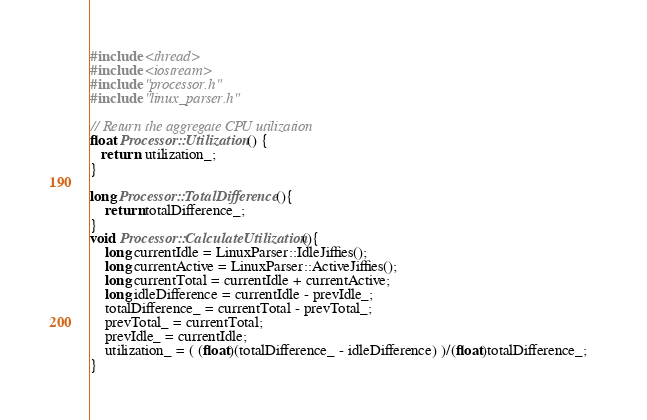<code> <loc_0><loc_0><loc_500><loc_500><_C++_>#include <thread>
#include <iostream>
#include "processor.h"
#include "linux_parser.h"

// Return the aggregate CPU utilization
float Processor::Utilization() {
   return  utilization_; 
}

long Processor::TotalDifference(){
    return totalDifference_;
}
void Processor::CalculateUtilization(){
    long currentIdle = LinuxParser::IdleJiffies();
    long currentActive = LinuxParser::ActiveJiffies();
    long currentTotal = currentIdle + currentActive;
    long idleDifference = currentIdle - prevIdle_;
    totalDifference_ = currentTotal - prevTotal_;
    prevTotal_ = currentTotal;
    prevIdle_ = currentIdle;
    utilization_ = ( (float)(totalDifference_ - idleDifference) )/(float)totalDifference_;   
}</code> 